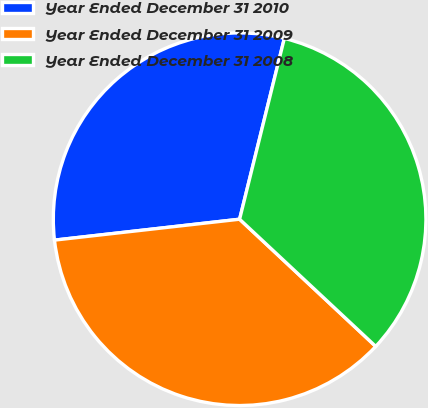Convert chart to OTSL. <chart><loc_0><loc_0><loc_500><loc_500><pie_chart><fcel>Year Ended December 31 2010<fcel>Year Ended December 31 2009<fcel>Year Ended December 31 2008<nl><fcel>30.65%<fcel>36.25%<fcel>33.1%<nl></chart> 